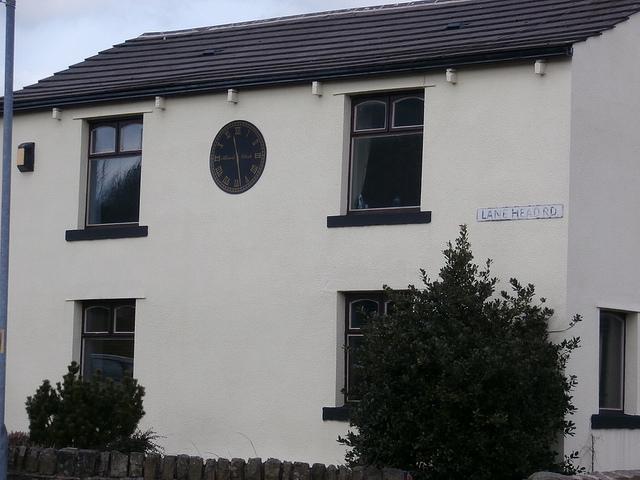How many vents are on the roof?
Give a very brief answer. 2. How many windows are pictured?
Give a very brief answer. 5. How many stories is this building?
Give a very brief answer. 2. How many people are wearing purple?
Give a very brief answer. 0. 